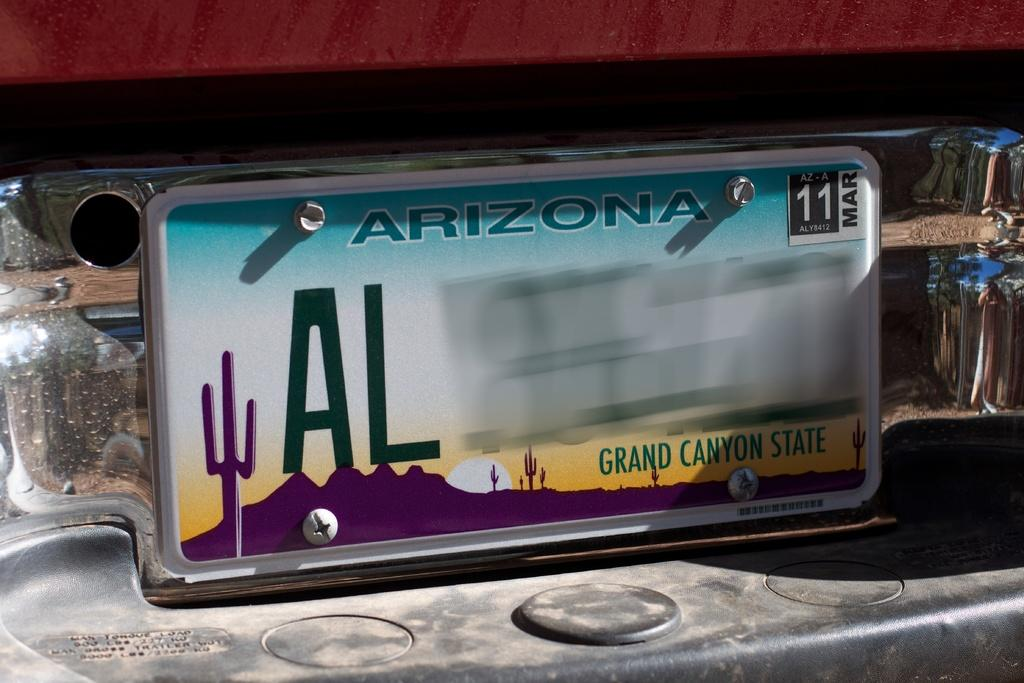Provide a one-sentence caption for the provided image. The license plate is from the city of Arizona. 